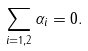Convert formula to latex. <formula><loc_0><loc_0><loc_500><loc_500>\sum _ { i = 1 , 2 } \alpha _ { i } = 0 .</formula> 